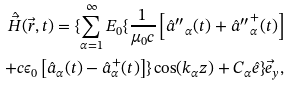Convert formula to latex. <formula><loc_0><loc_0><loc_500><loc_500>\hat { \vec { H } } ( \vec { r } , t ) = \{ \sum _ { \alpha = 1 } ^ { \infty } E _ { 0 } \{ \frac { 1 } { \mu _ { 0 } c } \left [ \hat { a } { ^ { \prime \prime } } _ { \alpha } ( t ) + \hat { a } { ^ { \prime \prime } } ^ { + } _ { \alpha } ( t ) \right ] \\ + c \epsilon _ { 0 } \left [ \hat { a } _ { \alpha } ( t ) - \hat { a } ^ { + } _ { \alpha } ( t ) \right ] \} \cos ( k _ { \alpha } z ) + C _ { \alpha } \hat { e } \} \vec { e } _ { y } ,</formula> 